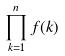Convert formula to latex. <formula><loc_0><loc_0><loc_500><loc_500>\prod _ { k = 1 } ^ { n } f ( k )</formula> 